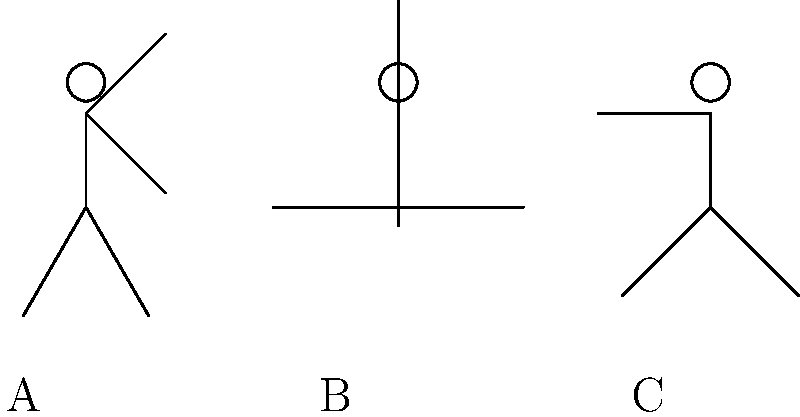As a storyteller highlighting the musical legacy of your neighborhood, you often discuss the impact of dance moves on the body. Which of the stick figure poses (A, B, or C) is likely to place the most stress on the knee joints during a prolonged dance routine? To determine which pose places the most stress on the knee joints, we need to consider the biomechanics of each position:

1. Pose A: The figure has a slight bend in the knees (approximately 30 degrees). This position distributes the body weight relatively evenly and doesn't place excessive stress on the knee joints.

2. Pose B: The figure has a deep squat position with the knees bent at about 90 degrees. This pose significantly increases the load on the knee joints due to:
   a) The increased flexion angle of the knee
   b) The body's center of mass being lowered, which increases the moment arm and thus the torque on the knee joint
   c) The quadriceps muscles working harder to maintain this position, which increases compressive forces on the patellofemoral joint

3. Pose C: The figure has one leg slightly bent (about 45 degrees) while the other is straight. This asymmetrical position doesn't place as much stress on the knees as Pose B, but it does create an uneven distribution of weight.

Among these three poses, Pose B places the most stress on the knee joints due to the deep squat position. This pose requires the knee to bear a significant portion of the body's weight while in a flexed position, which increases the compressive forces on the joint surfaces and the tension in the supporting ligaments and tendons.

Prolonged maintenance of this position or repetitive movement into and out of this pose during a dance routine would likely lead to the greatest accumulation of stress on the knee joints over time.
Answer: B 